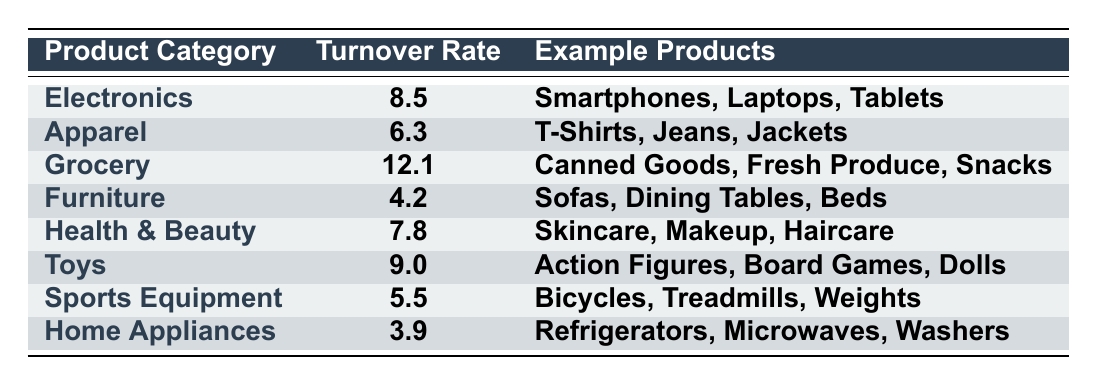What is the inventory turnover rate for Grocery? The table directly provides the turnover rate for each product category. For Grocery, it states the turnover rate is 12.1.
Answer: 12.1 Which product category has the highest turnover rate? The table lists the turnover rates for all categories. By scanning through the rates, Grocery has the highest value of 12.1.
Answer: Grocery What products are included in the Apparel category? The Apparel category in the table lists example products as T-Shirts, Jeans, and Jackets.
Answer: T-Shirts, Jeans, Jackets Is the turnover rate for Home Appliances higher than that for Sports Equipment? The turnover rate for Home Appliances is 3.9, while for Sports Equipment, it is 5.5. Since 3.9 is less than 5.5, the answer is no.
Answer: No What is the average turnover rate of Electronics and Toys? The turnover rate for Electronics is 8.5, and for Toys, it is 9.0. To find the average, add them: 8.5 + 9.0 = 17.5, then divide by 2: 17.5 / 2 = 8.75.
Answer: 8.75 How many product categories have a turnover rate above 7? By analyzing the table, the categories with rates above 7 are Electronics (8.5), Grocery (12.1), Health & Beauty (7.8), and Toys (9.0). This totals 4 categories.
Answer: 4 What is the difference in turnover rate between Furniture and Health & Beauty? The turnover rate for Furniture is 4.2, and for Health & Beauty, it is 7.8. The difference is calculated as 7.8 - 4.2 = 3.6.
Answer: 3.6 Which category has a turnover rate closest to the average turnover rate of Apparel and Sports Equipment? The turnover rate for Apparel is 6.3, and for Sports Equipment, it is 5.5. The average is (6.3 + 5.5) / 2 = 5.9. Comparing this with the table, Health & Beauty at 7.8 is the closest, though it's still above the average.
Answer: Health & Beauty Are there any product categories with a turnover rate of 4 or lower? Looking at the table, Home Appliances has a turnover rate of 3.9, which is 4 or lower, and Furniture is also below 4. Thus, there are categories with such rates.
Answer: Yes What percentage of the product categories have a turnover rate below 6? The categories with turnover rates below 6 are Furniture (4.2) and Home Appliances (3.9), which makes 2 out of 8 total categories. To find the percentage: (2 / 8) * 100 = 25%.
Answer: 25% 